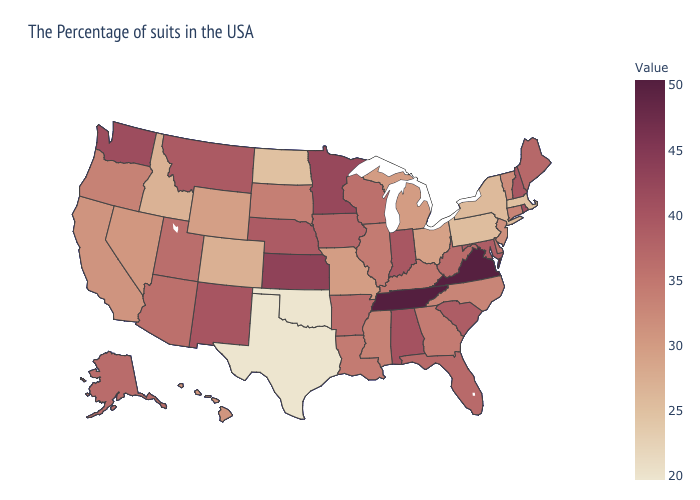Which states have the lowest value in the USA?
Quick response, please. Oklahoma, Texas. Among the states that border Kentucky , does Indiana have the lowest value?
Give a very brief answer. No. Does Texas have the lowest value in the South?
Quick response, please. Yes. Does Minnesota have a higher value than Florida?
Give a very brief answer. Yes. Is the legend a continuous bar?
Be succinct. Yes. 